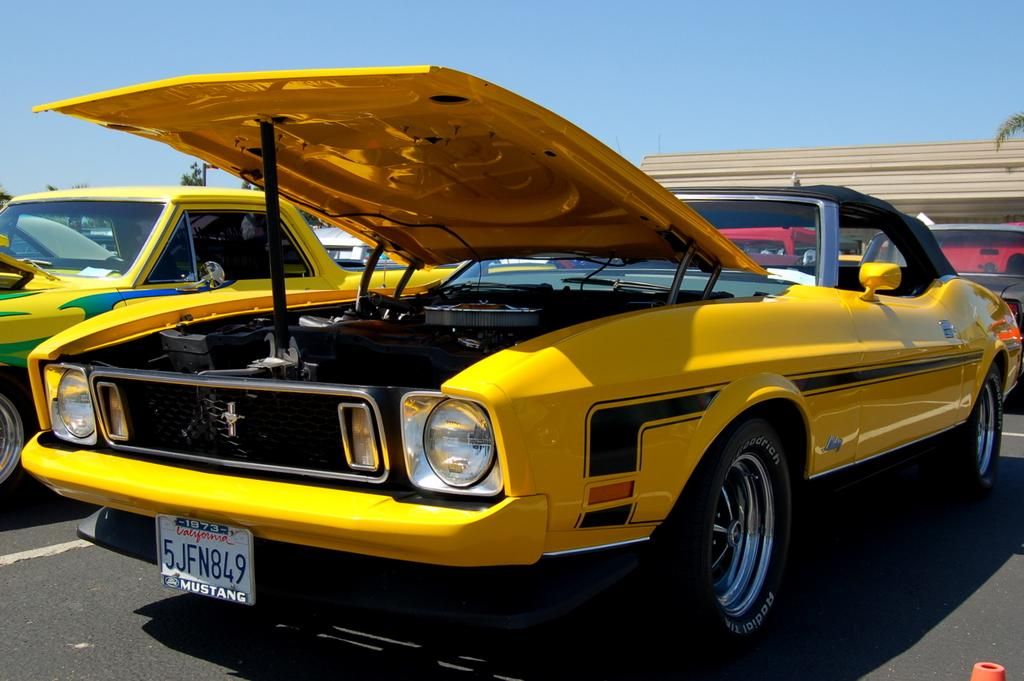<image>
Give a short and clear explanation of the subsequent image. The yellow convertible is on display somewhere in California. 